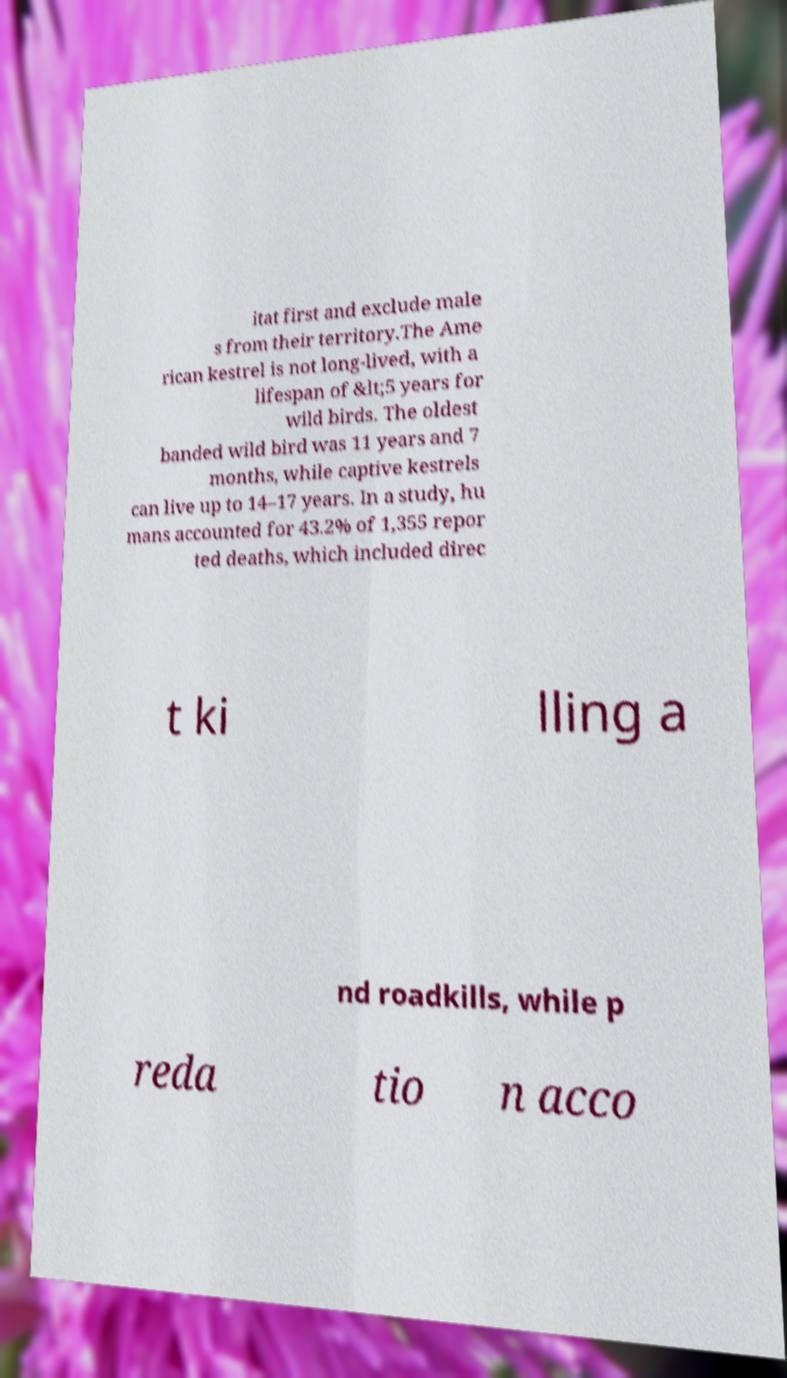Please read and relay the text visible in this image. What does it say? itat first and exclude male s from their territory.The Ame rican kestrel is not long-lived, with a lifespan of &lt;5 years for wild birds. The oldest banded wild bird was 11 years and 7 months, while captive kestrels can live up to 14–17 years. In a study, hu mans accounted for 43.2% of 1,355 repor ted deaths, which included direc t ki lling a nd roadkills, while p reda tio n acco 